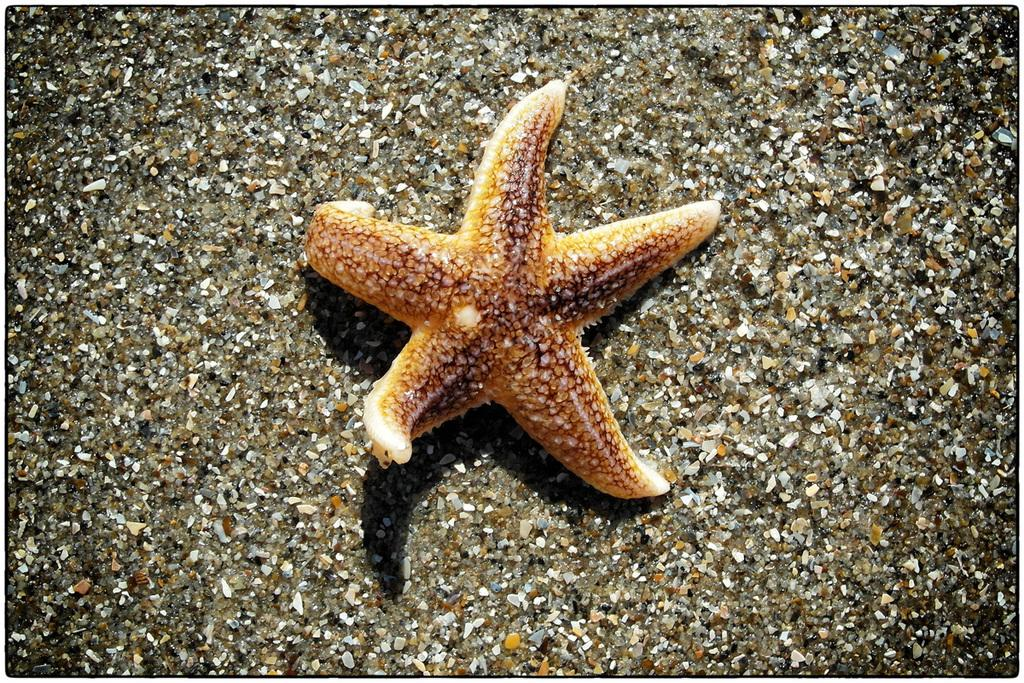What is the main subject of the image? The main subject of the image is a starfish. Where is the starfish located in the image? The starfish is on the sand surface of the ground. What type of collar is the governor wearing in the image? There is no governor or collar present in the image; it features a starfish on the sand. 